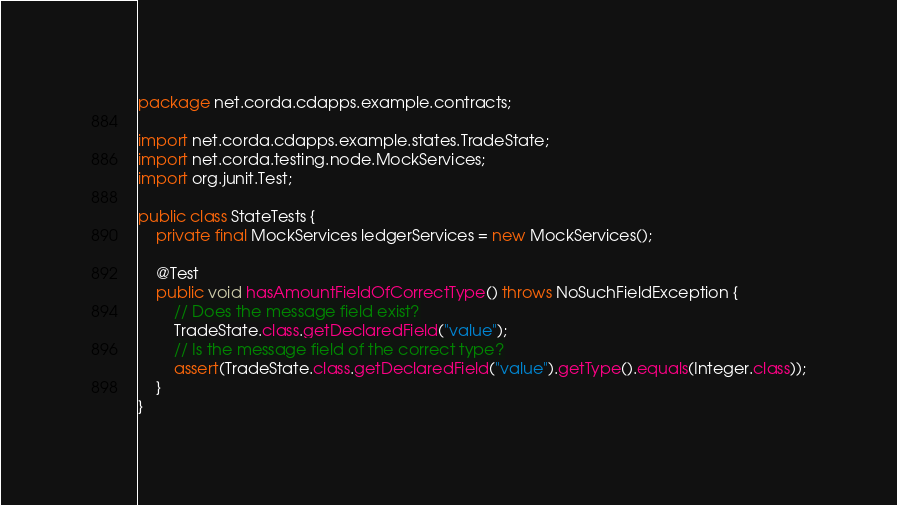Convert code to text. <code><loc_0><loc_0><loc_500><loc_500><_Java_>package net.corda.cdapps.example.contracts;

import net.corda.cdapps.example.states.TradeState;
import net.corda.testing.node.MockServices;
import org.junit.Test;

public class StateTests {
    private final MockServices ledgerServices = new MockServices();

    @Test
    public void hasAmountFieldOfCorrectType() throws NoSuchFieldException {
        // Does the message field exist?
        TradeState.class.getDeclaredField("value");
        // Is the message field of the correct type?
        assert(TradeState.class.getDeclaredField("value").getType().equals(Integer.class));
    }
}</code> 